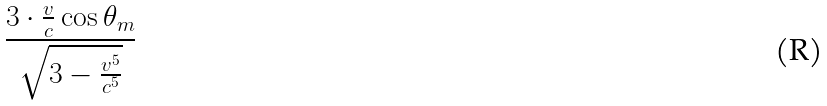Convert formula to latex. <formula><loc_0><loc_0><loc_500><loc_500>\frac { 3 \cdot \frac { v } { c } \cos \theta _ { m } } { \sqrt { 3 - \frac { v ^ { 5 } } { c ^ { 5 } } } }</formula> 